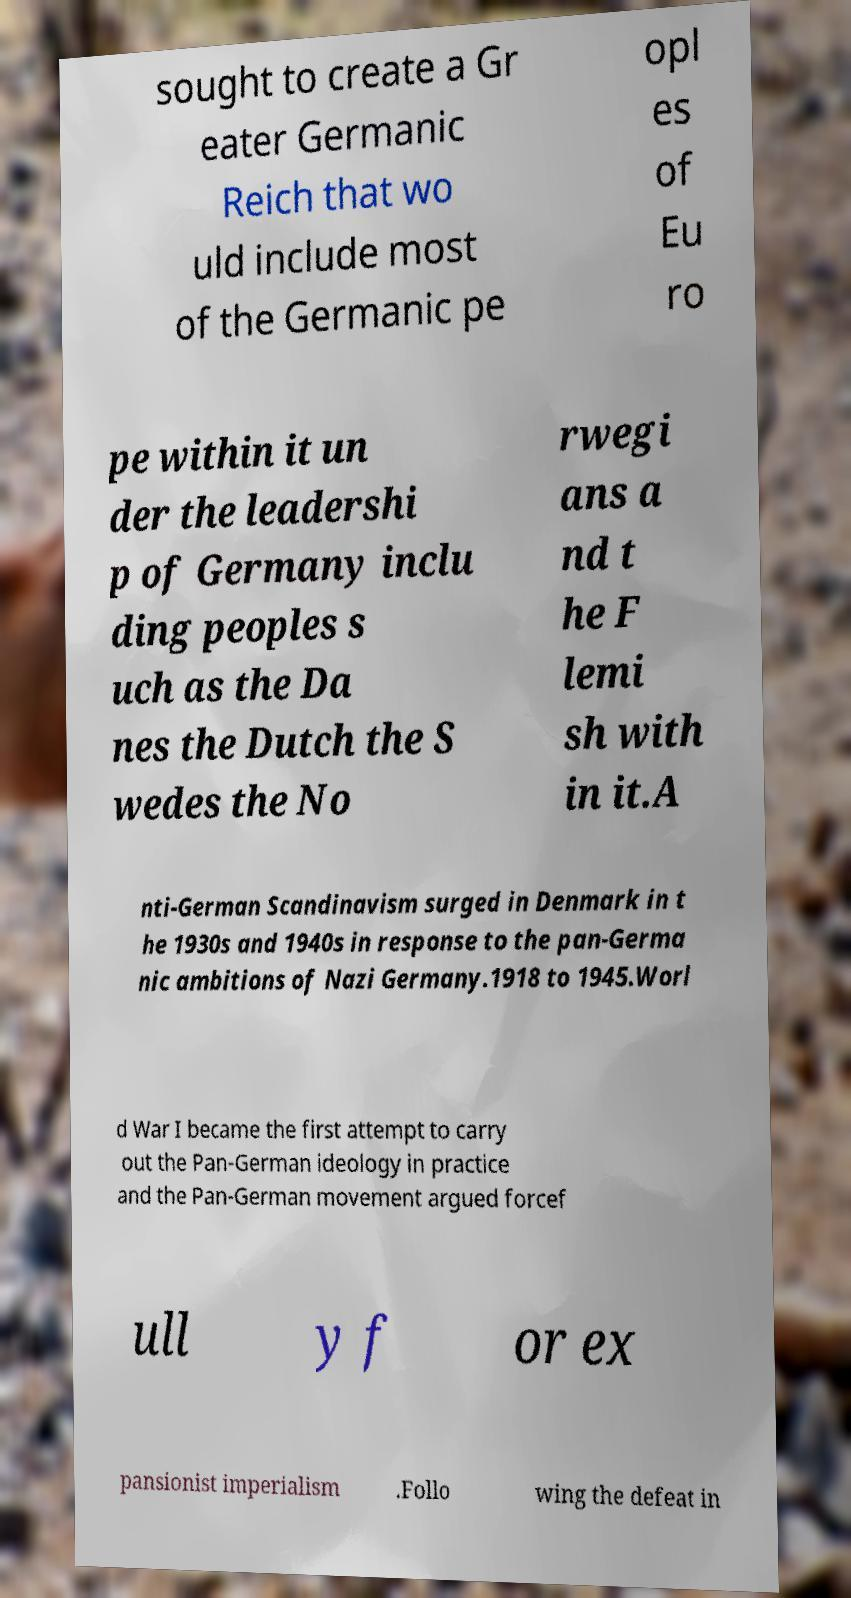There's text embedded in this image that I need extracted. Can you transcribe it verbatim? sought to create a Gr eater Germanic Reich that wo uld include most of the Germanic pe opl es of Eu ro pe within it un der the leadershi p of Germany inclu ding peoples s uch as the Da nes the Dutch the S wedes the No rwegi ans a nd t he F lemi sh with in it.A nti-German Scandinavism surged in Denmark in t he 1930s and 1940s in response to the pan-Germa nic ambitions of Nazi Germany.1918 to 1945.Worl d War I became the first attempt to carry out the Pan-German ideology in practice and the Pan-German movement argued forcef ull y f or ex pansionist imperialism .Follo wing the defeat in 